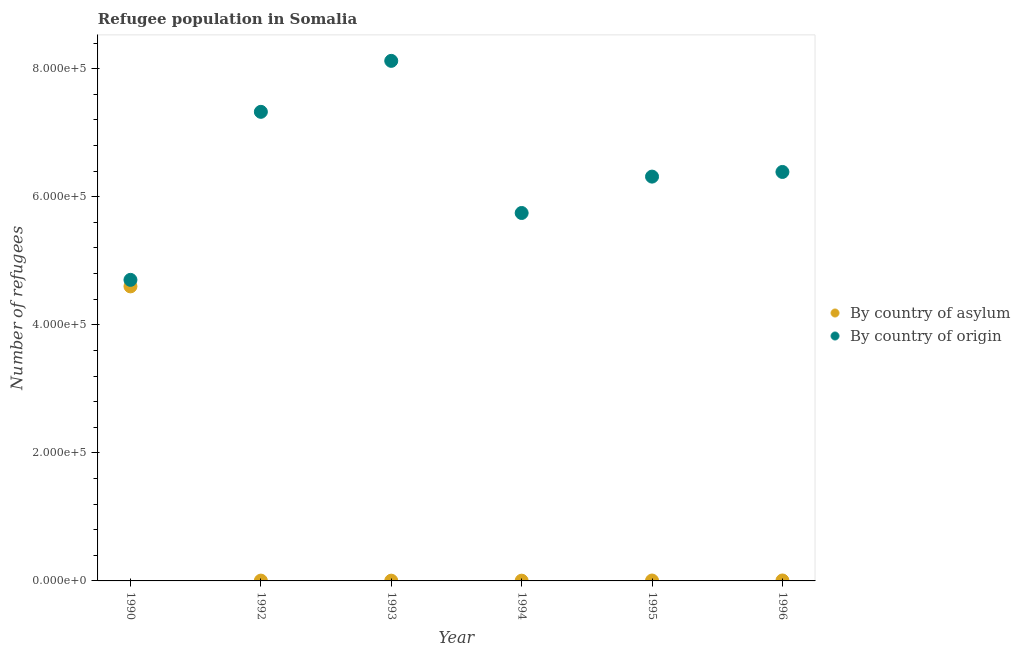What is the number of refugees by country of origin in 1994?
Your answer should be compact. 5.75e+05. Across all years, what is the maximum number of refugees by country of asylum?
Your answer should be compact. 4.60e+05. Across all years, what is the minimum number of refugees by country of asylum?
Your answer should be compact. 388. In which year was the number of refugees by country of asylum maximum?
Offer a terse response. 1990. What is the total number of refugees by country of origin in the graph?
Make the answer very short. 3.86e+06. What is the difference between the number of refugees by country of asylum in 1990 and that in 1996?
Offer a terse response. 4.59e+05. What is the difference between the number of refugees by country of asylum in 1994 and the number of refugees by country of origin in 1996?
Provide a short and direct response. -6.38e+05. What is the average number of refugees by country of origin per year?
Offer a very short reply. 6.43e+05. In the year 1995, what is the difference between the number of refugees by country of origin and number of refugees by country of asylum?
Give a very brief answer. 6.31e+05. What is the ratio of the number of refugees by country of origin in 1994 to that in 1995?
Keep it short and to the point. 0.91. What is the difference between the highest and the second highest number of refugees by country of origin?
Make the answer very short. 7.96e+04. What is the difference between the highest and the lowest number of refugees by country of asylum?
Provide a short and direct response. 4.60e+05. Does the number of refugees by country of asylum monotonically increase over the years?
Offer a terse response. No. How many dotlines are there?
Keep it short and to the point. 2. How many years are there in the graph?
Your answer should be compact. 6. What is the difference between two consecutive major ticks on the Y-axis?
Give a very brief answer. 2.00e+05. Does the graph contain any zero values?
Give a very brief answer. No. How many legend labels are there?
Offer a terse response. 2. What is the title of the graph?
Provide a succinct answer. Refugee population in Somalia. What is the label or title of the X-axis?
Your answer should be very brief. Year. What is the label or title of the Y-axis?
Your response must be concise. Number of refugees. What is the Number of refugees of By country of asylum in 1990?
Keep it short and to the point. 4.60e+05. What is the Number of refugees of By country of origin in 1990?
Give a very brief answer. 4.70e+05. What is the Number of refugees of By country of asylum in 1992?
Provide a succinct answer. 480. What is the Number of refugees of By country of origin in 1992?
Ensure brevity in your answer.  7.33e+05. What is the Number of refugees of By country of asylum in 1993?
Provide a succinct answer. 399. What is the Number of refugees of By country of origin in 1993?
Offer a terse response. 8.12e+05. What is the Number of refugees in By country of asylum in 1994?
Give a very brief answer. 388. What is the Number of refugees in By country of origin in 1994?
Ensure brevity in your answer.  5.75e+05. What is the Number of refugees of By country of asylum in 1995?
Provide a short and direct response. 626. What is the Number of refugees of By country of origin in 1995?
Your answer should be very brief. 6.31e+05. What is the Number of refugees of By country of asylum in 1996?
Provide a short and direct response. 700. What is the Number of refugees of By country of origin in 1996?
Keep it short and to the point. 6.39e+05. Across all years, what is the maximum Number of refugees in By country of origin?
Make the answer very short. 8.12e+05. Across all years, what is the minimum Number of refugees of By country of asylum?
Ensure brevity in your answer.  388. Across all years, what is the minimum Number of refugees in By country of origin?
Your answer should be very brief. 4.70e+05. What is the total Number of refugees of By country of asylum in the graph?
Your answer should be very brief. 4.63e+05. What is the total Number of refugees in By country of origin in the graph?
Offer a very short reply. 3.86e+06. What is the difference between the Number of refugees in By country of asylum in 1990 and that in 1992?
Your response must be concise. 4.60e+05. What is the difference between the Number of refugees of By country of origin in 1990 and that in 1992?
Keep it short and to the point. -2.62e+05. What is the difference between the Number of refugees in By country of asylum in 1990 and that in 1993?
Make the answer very short. 4.60e+05. What is the difference between the Number of refugees in By country of origin in 1990 and that in 1993?
Your answer should be very brief. -3.42e+05. What is the difference between the Number of refugees in By country of asylum in 1990 and that in 1994?
Your response must be concise. 4.60e+05. What is the difference between the Number of refugees of By country of origin in 1990 and that in 1994?
Make the answer very short. -1.04e+05. What is the difference between the Number of refugees of By country of asylum in 1990 and that in 1995?
Ensure brevity in your answer.  4.59e+05. What is the difference between the Number of refugees in By country of origin in 1990 and that in 1995?
Your response must be concise. -1.61e+05. What is the difference between the Number of refugees of By country of asylum in 1990 and that in 1996?
Your response must be concise. 4.59e+05. What is the difference between the Number of refugees in By country of origin in 1990 and that in 1996?
Make the answer very short. -1.69e+05. What is the difference between the Number of refugees of By country of asylum in 1992 and that in 1993?
Offer a terse response. 81. What is the difference between the Number of refugees in By country of origin in 1992 and that in 1993?
Your response must be concise. -7.96e+04. What is the difference between the Number of refugees in By country of asylum in 1992 and that in 1994?
Keep it short and to the point. 92. What is the difference between the Number of refugees of By country of origin in 1992 and that in 1994?
Make the answer very short. 1.58e+05. What is the difference between the Number of refugees in By country of asylum in 1992 and that in 1995?
Give a very brief answer. -146. What is the difference between the Number of refugees of By country of origin in 1992 and that in 1995?
Make the answer very short. 1.01e+05. What is the difference between the Number of refugees of By country of asylum in 1992 and that in 1996?
Your answer should be compact. -220. What is the difference between the Number of refugees of By country of origin in 1992 and that in 1996?
Ensure brevity in your answer.  9.39e+04. What is the difference between the Number of refugees of By country of asylum in 1993 and that in 1994?
Your answer should be compact. 11. What is the difference between the Number of refugees of By country of origin in 1993 and that in 1994?
Offer a very short reply. 2.38e+05. What is the difference between the Number of refugees in By country of asylum in 1993 and that in 1995?
Keep it short and to the point. -227. What is the difference between the Number of refugees of By country of origin in 1993 and that in 1995?
Give a very brief answer. 1.81e+05. What is the difference between the Number of refugees of By country of asylum in 1993 and that in 1996?
Your answer should be very brief. -301. What is the difference between the Number of refugees of By country of origin in 1993 and that in 1996?
Provide a succinct answer. 1.73e+05. What is the difference between the Number of refugees of By country of asylum in 1994 and that in 1995?
Your answer should be compact. -238. What is the difference between the Number of refugees in By country of origin in 1994 and that in 1995?
Your answer should be very brief. -5.68e+04. What is the difference between the Number of refugees in By country of asylum in 1994 and that in 1996?
Provide a short and direct response. -312. What is the difference between the Number of refugees of By country of origin in 1994 and that in 1996?
Your answer should be very brief. -6.41e+04. What is the difference between the Number of refugees in By country of asylum in 1995 and that in 1996?
Your answer should be very brief. -74. What is the difference between the Number of refugees in By country of origin in 1995 and that in 1996?
Your response must be concise. -7272. What is the difference between the Number of refugees of By country of asylum in 1990 and the Number of refugees of By country of origin in 1992?
Make the answer very short. -2.73e+05. What is the difference between the Number of refugees in By country of asylum in 1990 and the Number of refugees in By country of origin in 1993?
Keep it short and to the point. -3.52e+05. What is the difference between the Number of refugees of By country of asylum in 1990 and the Number of refugees of By country of origin in 1994?
Keep it short and to the point. -1.15e+05. What is the difference between the Number of refugees in By country of asylum in 1990 and the Number of refugees in By country of origin in 1995?
Make the answer very short. -1.71e+05. What is the difference between the Number of refugees of By country of asylum in 1990 and the Number of refugees of By country of origin in 1996?
Provide a succinct answer. -1.79e+05. What is the difference between the Number of refugees in By country of asylum in 1992 and the Number of refugees in By country of origin in 1993?
Offer a very short reply. -8.12e+05. What is the difference between the Number of refugees in By country of asylum in 1992 and the Number of refugees in By country of origin in 1994?
Give a very brief answer. -5.74e+05. What is the difference between the Number of refugees in By country of asylum in 1992 and the Number of refugees in By country of origin in 1995?
Provide a succinct answer. -6.31e+05. What is the difference between the Number of refugees of By country of asylum in 1992 and the Number of refugees of By country of origin in 1996?
Your answer should be compact. -6.38e+05. What is the difference between the Number of refugees in By country of asylum in 1993 and the Number of refugees in By country of origin in 1994?
Make the answer very short. -5.74e+05. What is the difference between the Number of refugees of By country of asylum in 1993 and the Number of refugees of By country of origin in 1995?
Your response must be concise. -6.31e+05. What is the difference between the Number of refugees of By country of asylum in 1993 and the Number of refugees of By country of origin in 1996?
Your response must be concise. -6.38e+05. What is the difference between the Number of refugees in By country of asylum in 1994 and the Number of refugees in By country of origin in 1995?
Offer a terse response. -6.31e+05. What is the difference between the Number of refugees in By country of asylum in 1994 and the Number of refugees in By country of origin in 1996?
Provide a short and direct response. -6.38e+05. What is the difference between the Number of refugees in By country of asylum in 1995 and the Number of refugees in By country of origin in 1996?
Give a very brief answer. -6.38e+05. What is the average Number of refugees of By country of asylum per year?
Provide a succinct answer. 7.71e+04. What is the average Number of refugees of By country of origin per year?
Keep it short and to the point. 6.43e+05. In the year 1990, what is the difference between the Number of refugees in By country of asylum and Number of refugees in By country of origin?
Your answer should be very brief. -1.02e+04. In the year 1992, what is the difference between the Number of refugees of By country of asylum and Number of refugees of By country of origin?
Make the answer very short. -7.32e+05. In the year 1993, what is the difference between the Number of refugees of By country of asylum and Number of refugees of By country of origin?
Keep it short and to the point. -8.12e+05. In the year 1994, what is the difference between the Number of refugees in By country of asylum and Number of refugees in By country of origin?
Ensure brevity in your answer.  -5.74e+05. In the year 1995, what is the difference between the Number of refugees in By country of asylum and Number of refugees in By country of origin?
Offer a terse response. -6.31e+05. In the year 1996, what is the difference between the Number of refugees in By country of asylum and Number of refugees in By country of origin?
Your answer should be compact. -6.38e+05. What is the ratio of the Number of refugees of By country of asylum in 1990 to that in 1992?
Give a very brief answer. 958.33. What is the ratio of the Number of refugees in By country of origin in 1990 to that in 1992?
Provide a succinct answer. 0.64. What is the ratio of the Number of refugees of By country of asylum in 1990 to that in 1993?
Ensure brevity in your answer.  1152.88. What is the ratio of the Number of refugees in By country of origin in 1990 to that in 1993?
Ensure brevity in your answer.  0.58. What is the ratio of the Number of refugees in By country of asylum in 1990 to that in 1994?
Your response must be concise. 1185.57. What is the ratio of the Number of refugees of By country of origin in 1990 to that in 1994?
Keep it short and to the point. 0.82. What is the ratio of the Number of refugees of By country of asylum in 1990 to that in 1995?
Your answer should be compact. 734.82. What is the ratio of the Number of refugees of By country of origin in 1990 to that in 1995?
Your answer should be very brief. 0.74. What is the ratio of the Number of refugees of By country of asylum in 1990 to that in 1996?
Your answer should be very brief. 657.14. What is the ratio of the Number of refugees in By country of origin in 1990 to that in 1996?
Your response must be concise. 0.74. What is the ratio of the Number of refugees in By country of asylum in 1992 to that in 1993?
Give a very brief answer. 1.2. What is the ratio of the Number of refugees in By country of origin in 1992 to that in 1993?
Keep it short and to the point. 0.9. What is the ratio of the Number of refugees of By country of asylum in 1992 to that in 1994?
Keep it short and to the point. 1.24. What is the ratio of the Number of refugees of By country of origin in 1992 to that in 1994?
Provide a succinct answer. 1.27. What is the ratio of the Number of refugees in By country of asylum in 1992 to that in 1995?
Your answer should be very brief. 0.77. What is the ratio of the Number of refugees of By country of origin in 1992 to that in 1995?
Your response must be concise. 1.16. What is the ratio of the Number of refugees of By country of asylum in 1992 to that in 1996?
Ensure brevity in your answer.  0.69. What is the ratio of the Number of refugees of By country of origin in 1992 to that in 1996?
Make the answer very short. 1.15. What is the ratio of the Number of refugees in By country of asylum in 1993 to that in 1994?
Offer a very short reply. 1.03. What is the ratio of the Number of refugees of By country of origin in 1993 to that in 1994?
Your response must be concise. 1.41. What is the ratio of the Number of refugees of By country of asylum in 1993 to that in 1995?
Provide a succinct answer. 0.64. What is the ratio of the Number of refugees in By country of origin in 1993 to that in 1995?
Ensure brevity in your answer.  1.29. What is the ratio of the Number of refugees of By country of asylum in 1993 to that in 1996?
Your answer should be compact. 0.57. What is the ratio of the Number of refugees of By country of origin in 1993 to that in 1996?
Make the answer very short. 1.27. What is the ratio of the Number of refugees of By country of asylum in 1994 to that in 1995?
Provide a short and direct response. 0.62. What is the ratio of the Number of refugees of By country of origin in 1994 to that in 1995?
Provide a short and direct response. 0.91. What is the ratio of the Number of refugees of By country of asylum in 1994 to that in 1996?
Offer a very short reply. 0.55. What is the ratio of the Number of refugees of By country of origin in 1994 to that in 1996?
Offer a terse response. 0.9. What is the ratio of the Number of refugees in By country of asylum in 1995 to that in 1996?
Offer a very short reply. 0.89. What is the difference between the highest and the second highest Number of refugees in By country of asylum?
Offer a very short reply. 4.59e+05. What is the difference between the highest and the second highest Number of refugees in By country of origin?
Provide a succinct answer. 7.96e+04. What is the difference between the highest and the lowest Number of refugees of By country of asylum?
Offer a very short reply. 4.60e+05. What is the difference between the highest and the lowest Number of refugees in By country of origin?
Ensure brevity in your answer.  3.42e+05. 